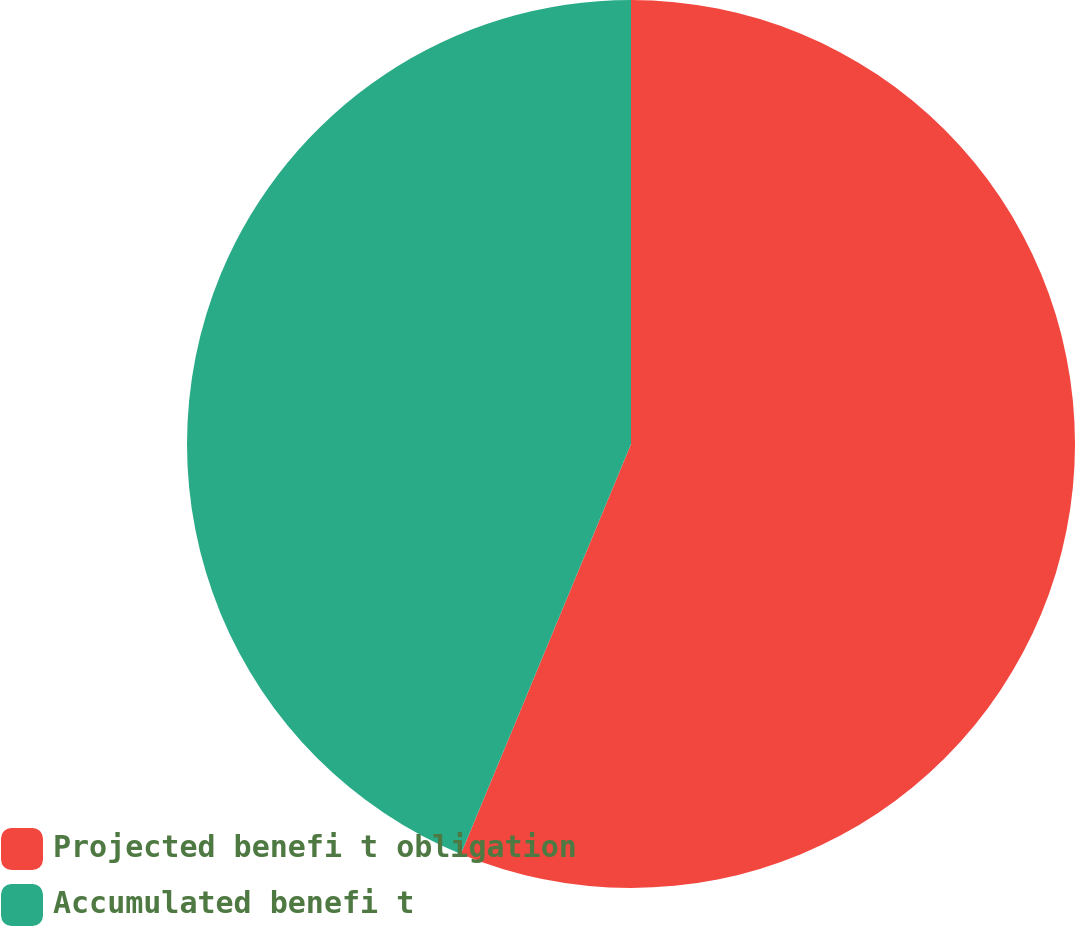Convert chart to OTSL. <chart><loc_0><loc_0><loc_500><loc_500><pie_chart><fcel>Projected benefi t obligation<fcel>Accumulated benefi t<nl><fcel>56.26%<fcel>43.74%<nl></chart> 